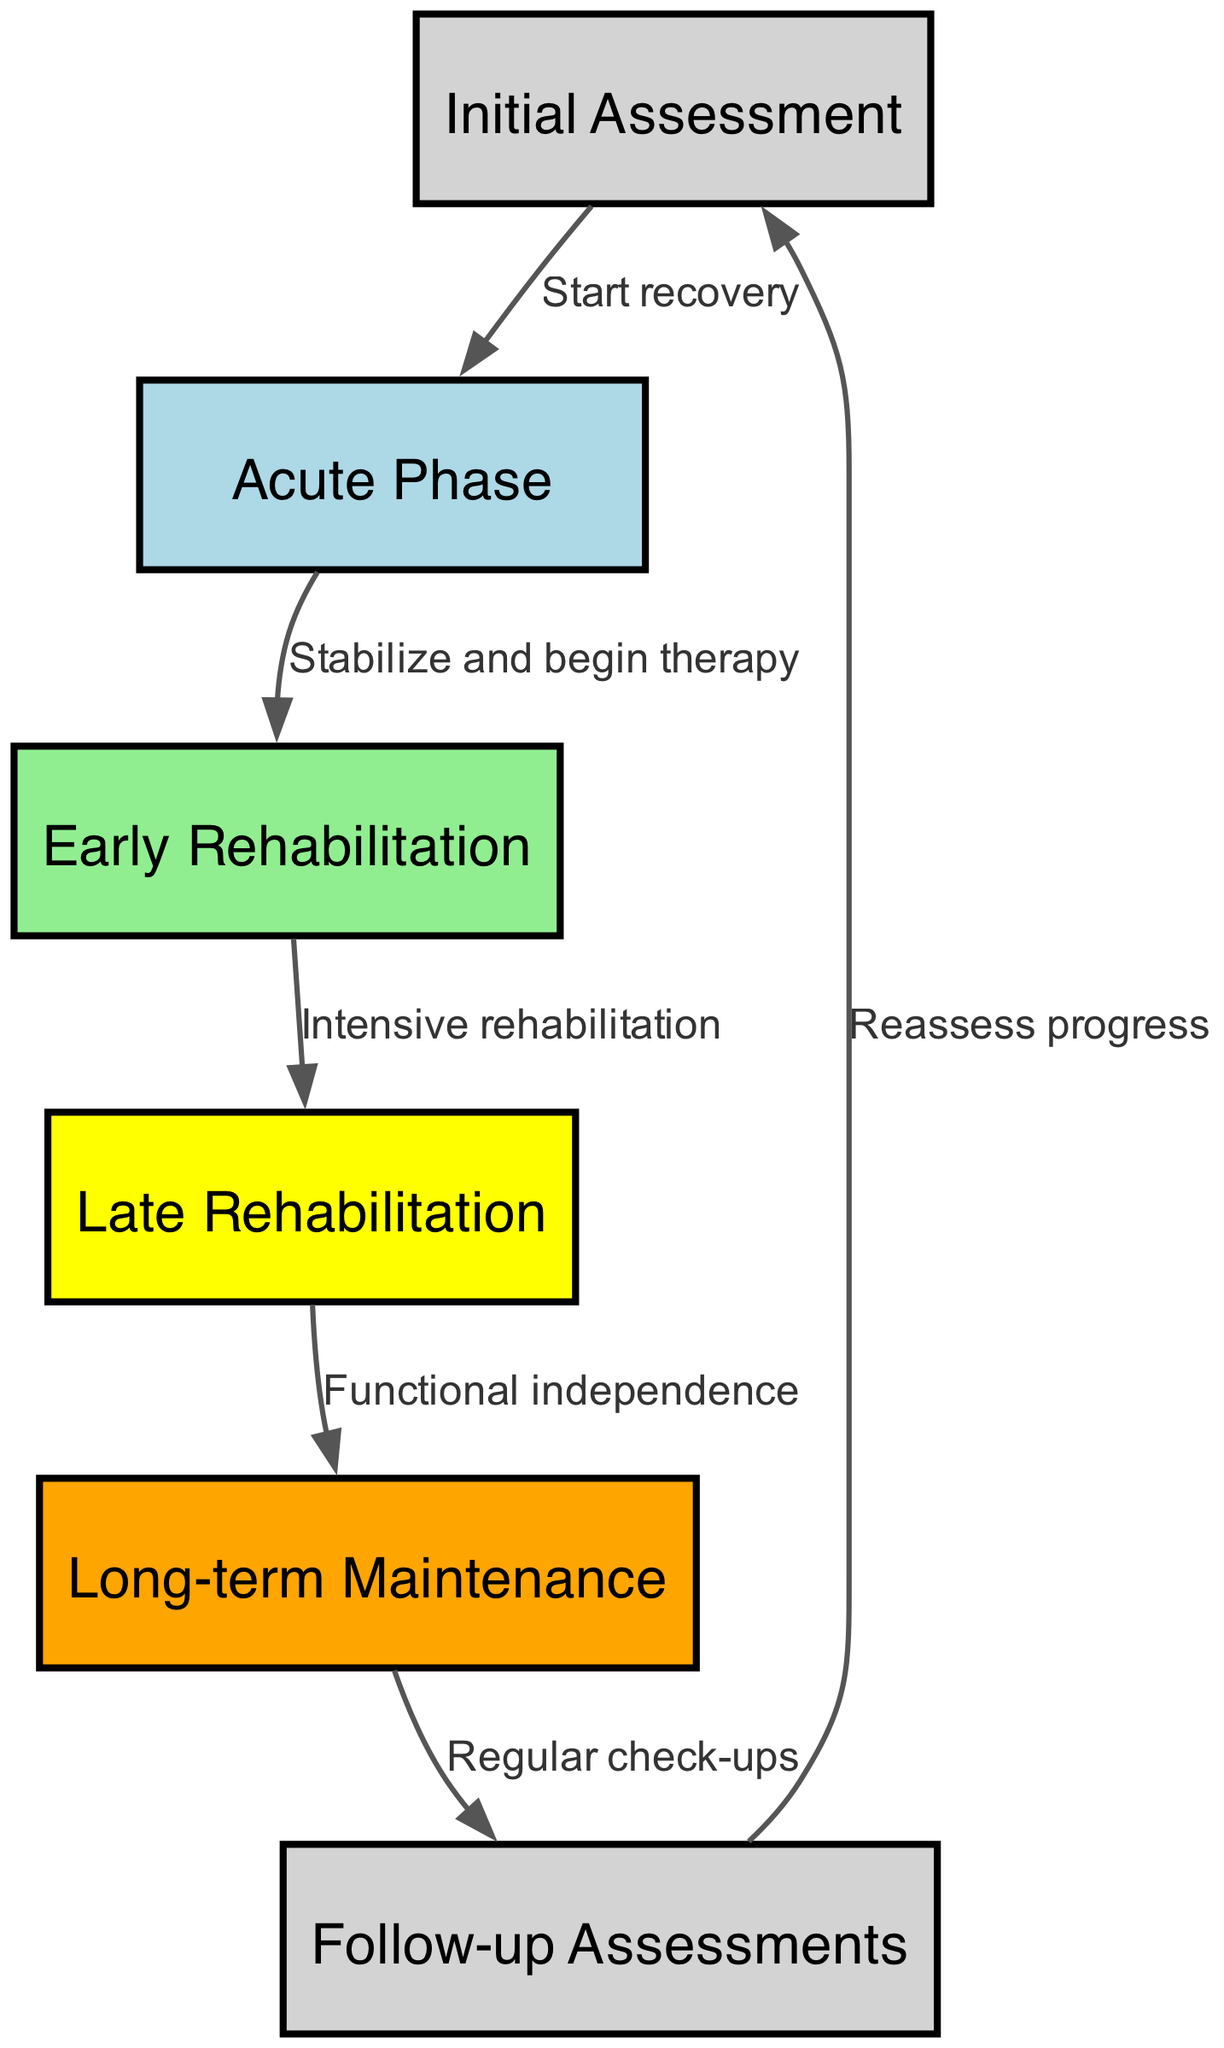What's the first stage of recovery? The diagram indicates that the first stage of recovery is the "Initial Assessment," which is the starting point before transitioning into further recovery phases.
Answer: Initial Assessment How many total nodes are there in the diagram? By counting all the nodes listed—Initial Assessment, Acute Phase, Early Rehabilitation, Late Rehabilitation, Long-term Maintenance, and Follow-up Assessments—we find there are a total of six nodes.
Answer: Six What color represents the Late Rehabilitation stage? The diagram shows that the Late Rehabilitation stage is represented by the color yellow, which distinguishes it from other stages through color coding.
Answer: Yellow What is the relationship between the Acute Phase and Early Rehabilitation? The relationship is indicated by a directional arrow showing that the Acute Phase leads into the Early Rehabilitation phase, implying that after stabilizing, the therapy effort begins.
Answer: Stabilize and begin therapy What stage follows Long-term Maintenance? According to the diagram, after the Long-term Maintenance stage, the next stage is Follow-up Assessments, indicating a cycle to reassess progress after achieving long-term care.
Answer: Follow-up Assessments How many edges connect the nodes in total? Each edge connects one node to another, and counting the connections shown, there are a total of five edges leading from one stage to the next throughout the entire recovery process.
Answer: Five What transitions occur after the Late Rehabilitation stage? The transition occurring after the Late Rehabilitation stage is to the Long-term Maintenance stage, which represents moving towards greater functional independence.
Answer: Functional independence What is the final step in the recovery flow? The diagram indicates that the final step in the recovery flow is the Reassess progress, which connects back to the Initial Assessment, completing the review cycle of recovery.
Answer: Reassess progress 